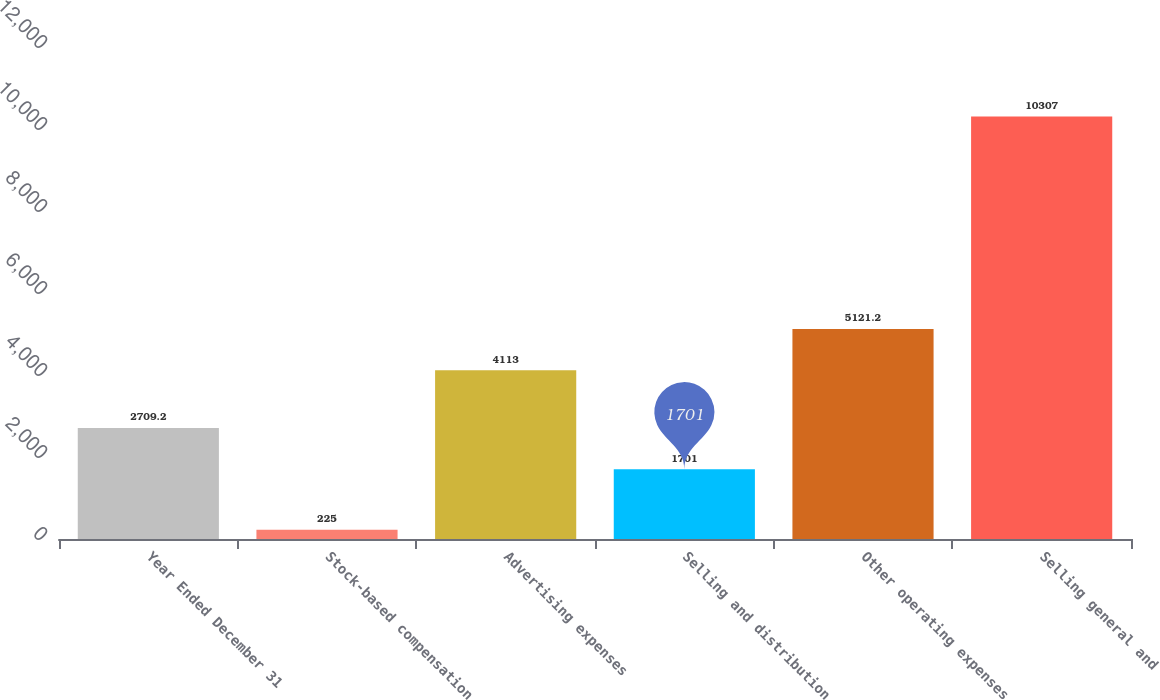<chart> <loc_0><loc_0><loc_500><loc_500><bar_chart><fcel>Year Ended December 31<fcel>Stock-based compensation<fcel>Advertising expenses<fcel>Selling and distribution<fcel>Other operating expenses<fcel>Selling general and<nl><fcel>2709.2<fcel>225<fcel>4113<fcel>1701<fcel>5121.2<fcel>10307<nl></chart> 